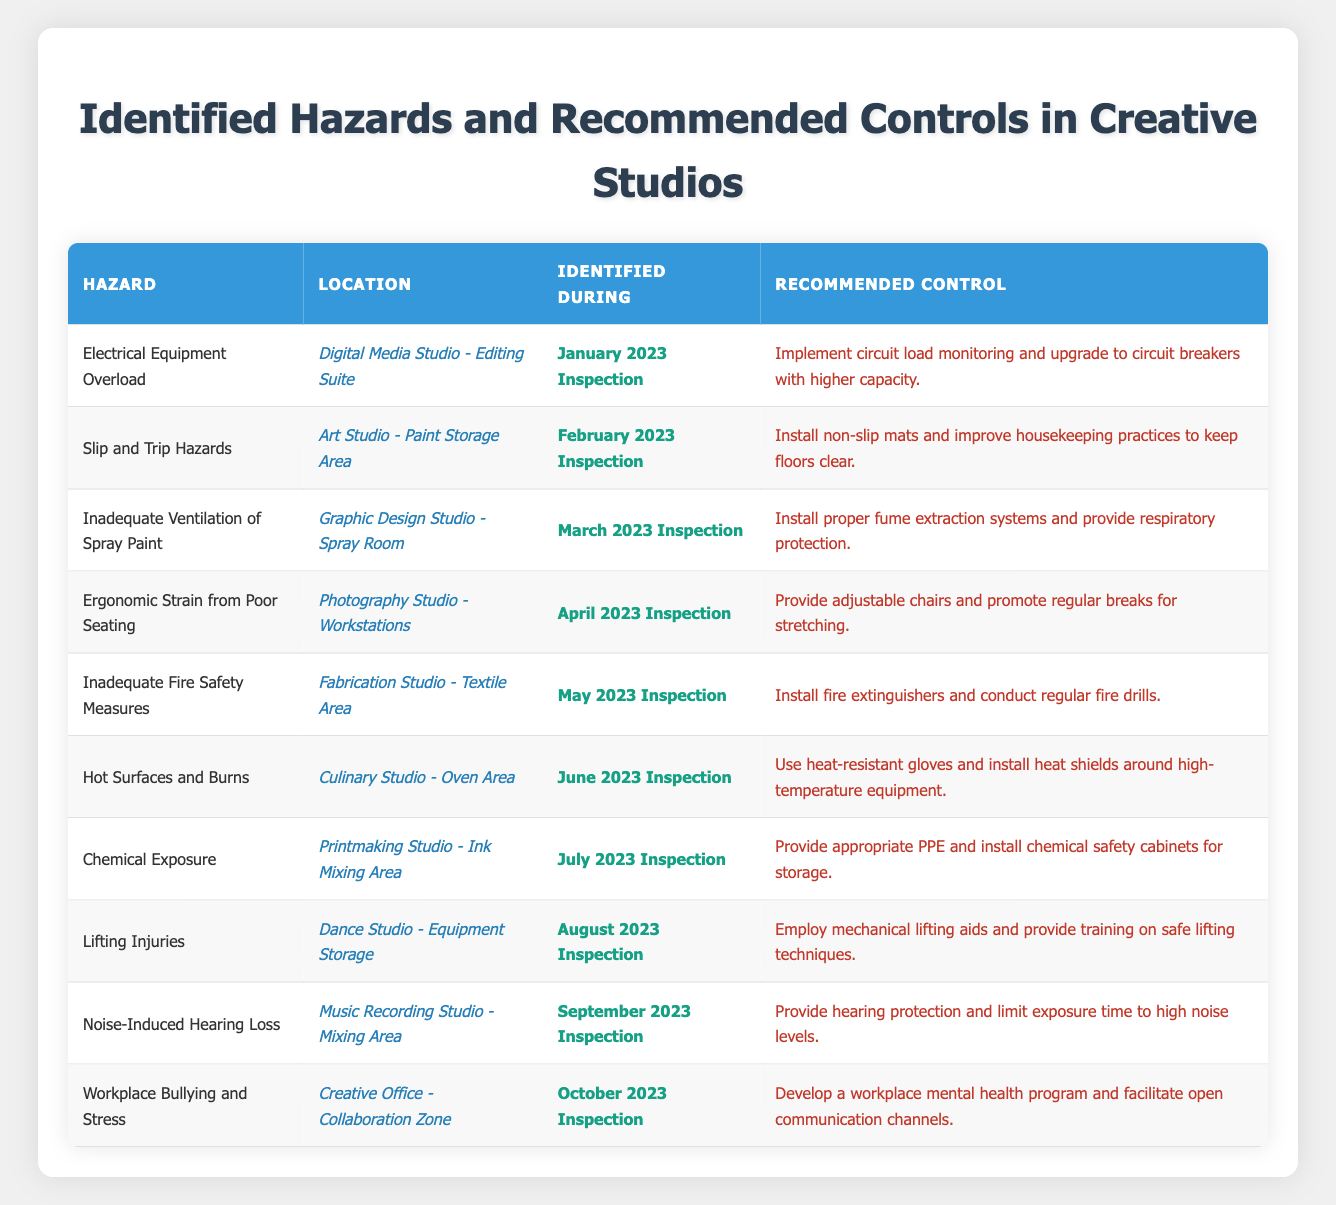What hazard was identified in the Digital Media Studio? The table lists the hazards and locations. In the Digital Media Studio under the Editing Suite, the identified hazard is "Electrical Equipment Overload."
Answer: Electrical Equipment Overload Which area had slip and trip hazards identified? Referring to the table, the area with slip and trip hazards is the "Art Studio - Paint Storage Area."
Answer: Art Studio - Paint Storage Area How many hazards were identified in March 2023? The table is checked for entries in March 2023 and shows one entry for "Inadequate Ventilation of Spray Paint."
Answer: 1 What is the recommended control for noise-induced hearing loss? Looking at the entry for noise-induced hearing loss under the Music Recording Studio, it recommends providing hearing protection and limiting exposure time.
Answer: Provide hearing protection and limit exposure time Is there a recommendation for improving seating ergonomics in the Photography Studio? The entry for the Photography Studio mentions providing adjustable chairs and promoting regular breaks for stretching, which indicates a recommendation for improving seating ergonomics.
Answer: Yes Which location had an identified hazard related to chemical exposure? The table specifies the "Printmaking Studio - Ink Mixing Area" as the location where chemical exposure was identified as a hazard.
Answer: Printmaking Studio - Ink Mixing Area What are the total number of fire safety measures recommended? The table indicates one hazard related to inadequate fire safety measures in the Fabrication Studio, which recommends installing fire extinguishers and conducting fire drills, counting as a single set of fire safety measures.
Answer: 1 How many different hazards identified are related to safety equipment? By examining the table, the hazards related to safety equipment are: Inadequate Fire Safety Measures, Hot Surfaces and Burns, and Chemical Exposure. This totals three distinct hazards related to safety equipment.
Answer: 3 Which month had the highest number of identified hazards? Evaluating the table, each month has only one hazard listed. Therefore, there is no month with more than one hazard identified; all months have the same number of hazards.
Answer: None; all months have the same number What is the most recent hazard identified and where? The most recent entry is from October 2023, which identifies "Workplace Bullying and Stress" in the "Creative Office - Collaboration Zone."
Answer: Workplace Bullying and Stress in Creative Office - Collaboration Zone What specific control measures are recommended for lifting injuries? Under the hazard of lifting injuries in the Dance Studio, it recommends employing mechanical lifting aids and providing training on safe lifting techniques.
Answer: Employ mechanical lifting aids and provide training on safe lifting techniques 